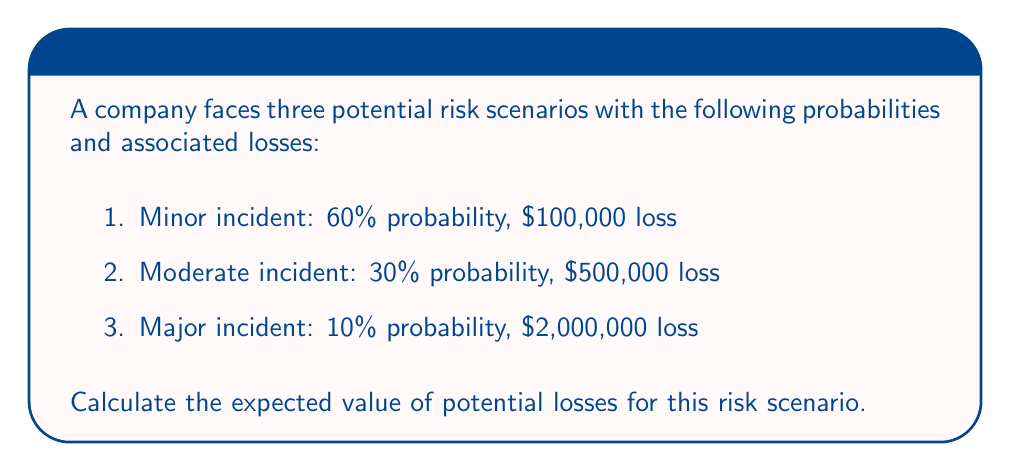Can you solve this math problem? To calculate the expected value of potential losses, we need to follow these steps:

1. Recall the formula for expected value:
   $$E(X) = \sum_{i=1}^{n} p_i \cdot x_i$$
   where $p_i$ is the probability of each outcome and $x_i$ is the value of each outcome.

2. Identify the probabilities and losses for each scenario:
   - Scenario 1: $p_1 = 0.60$, $x_1 = 100,000$
   - Scenario 2: $p_2 = 0.30$, $x_2 = 500,000$
   - Scenario 3: $p_3 = 0.10$, $x_3 = 2,000,000$

3. Apply the formula:
   $$E(X) = (0.60 \cdot 100,000) + (0.30 \cdot 500,000) + (0.10 \cdot 2,000,000)$$

4. Calculate each term:
   $$E(X) = 60,000 + 150,000 + 200,000$$

5. Sum up the results:
   $$E(X) = 410,000$$

Therefore, the expected value of potential losses in this risk scenario is $410,000.
Answer: $410,000 